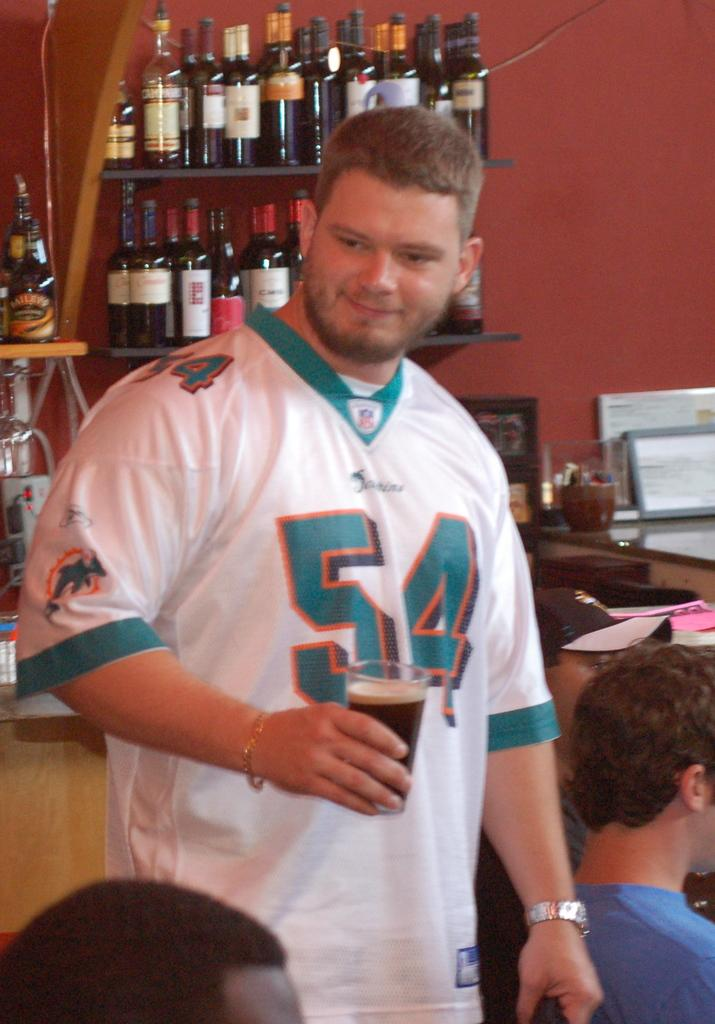What is the person in the image holding? The person is holding a glass with a drink in the image. Can you describe the surroundings of the person? There are other people around the person in the image. What can be seen in the background of the image? There are bottles on shelves visible in the background of the image. What color of paint is being used by the person in the image? There is no paint or painting activity present in the image. Is the person in the image in jail? There is no indication in the image that the person is in jail. 